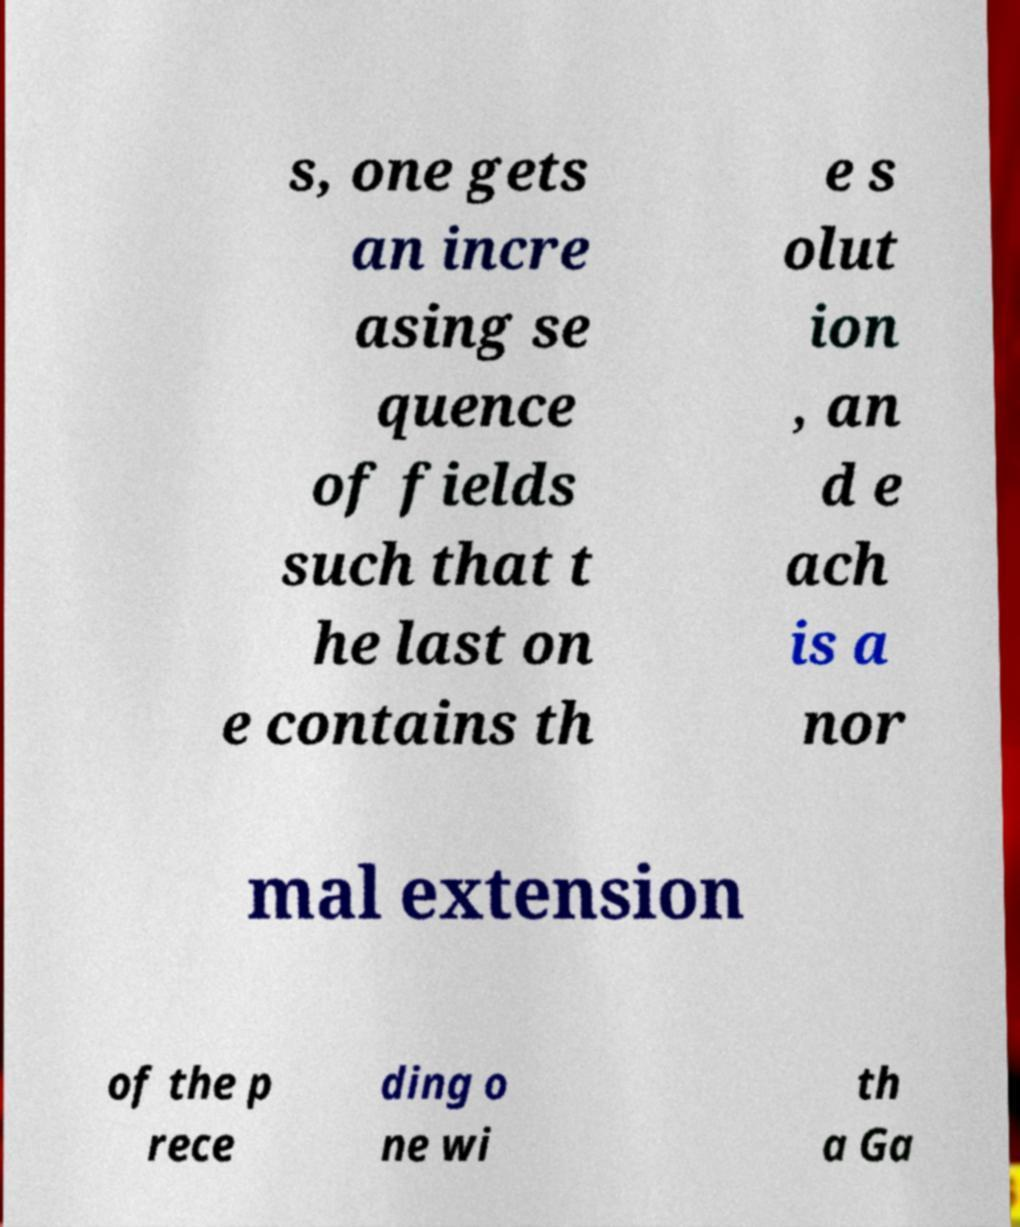Can you read and provide the text displayed in the image?This photo seems to have some interesting text. Can you extract and type it out for me? s, one gets an incre asing se quence of fields such that t he last on e contains th e s olut ion , an d e ach is a nor mal extension of the p rece ding o ne wi th a Ga 